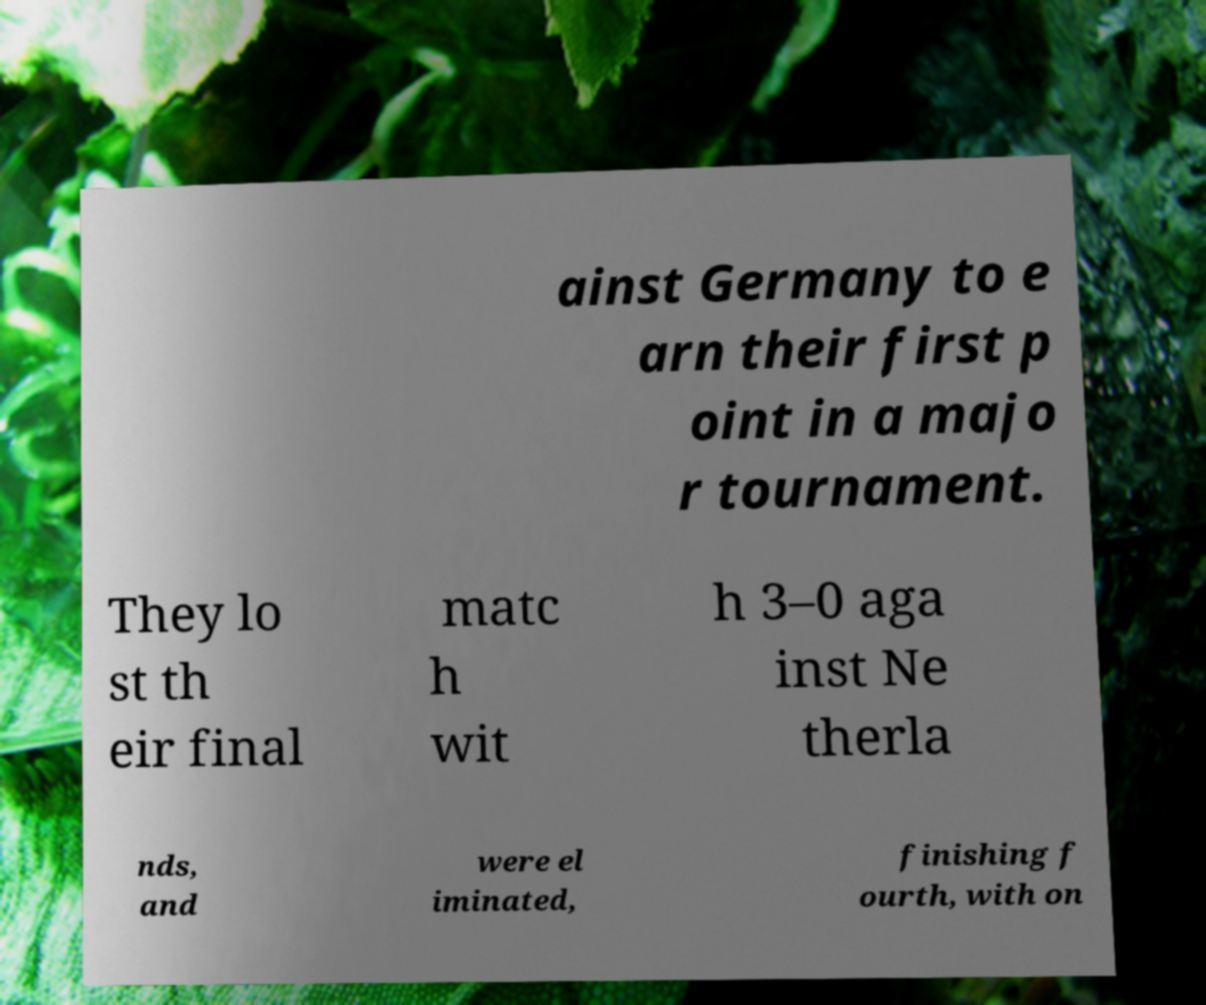There's text embedded in this image that I need extracted. Can you transcribe it verbatim? ainst Germany to e arn their first p oint in a majo r tournament. They lo st th eir final matc h wit h 3–0 aga inst Ne therla nds, and were el iminated, finishing f ourth, with on 